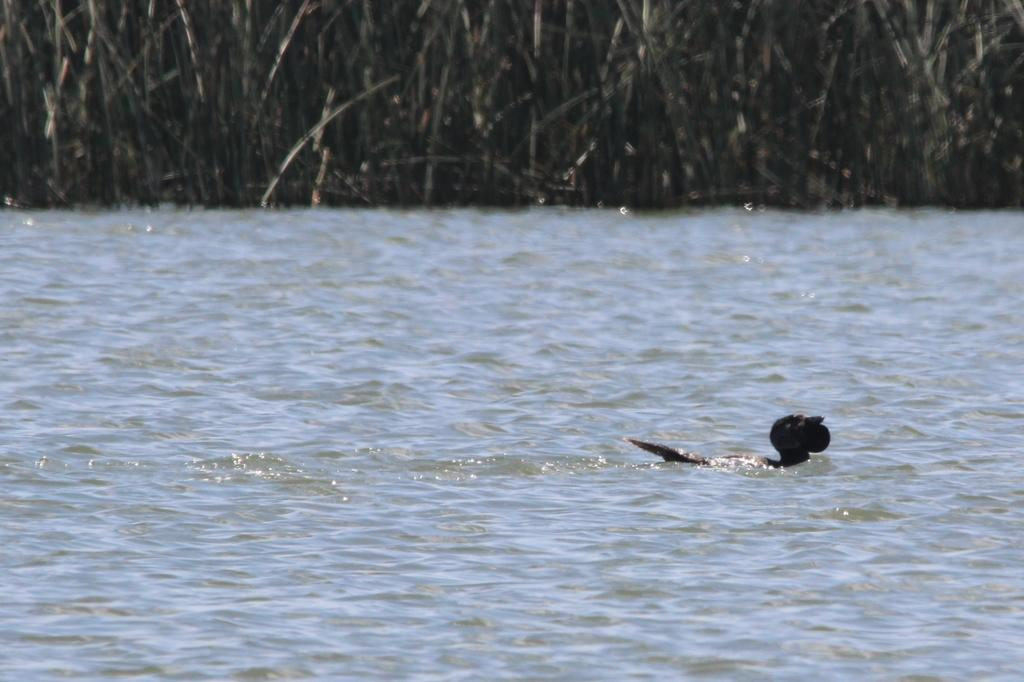What type of animal can be seen in the image? There is a bird in the image. What is the primary element in which the bird is situated? There is water visible in the image, and the bird is situated in it. What can be seen in the background of the image? There is grass in the background of the image. What type of building can be seen in the image? There is no building present in the image; it features a bird in water with grass in the background. What kind of apparatus is being used by the bird in the image? There is no apparatus visible in the image; it simply shows a bird in water. 